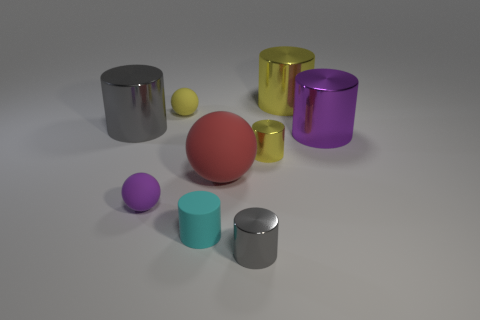Add 1 gray objects. How many objects exist? 10 Subtract all gray cylinders. How many cylinders are left? 4 Subtract all green blocks. How many yellow cylinders are left? 2 Subtract 2 cylinders. How many cylinders are left? 4 Subtract all spheres. How many objects are left? 6 Subtract all yellow cylinders. How many cylinders are left? 4 Subtract all red cylinders. Subtract all green cubes. How many cylinders are left? 6 Subtract all purple cylinders. Subtract all red cylinders. How many objects are left? 8 Add 1 red rubber balls. How many red rubber balls are left? 2 Add 5 gray blocks. How many gray blocks exist? 5 